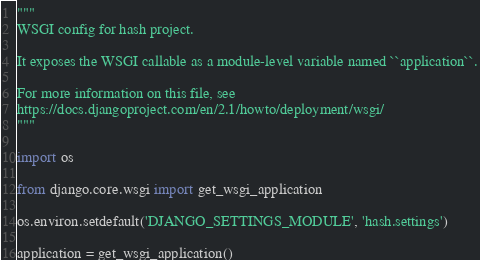Convert code to text. <code><loc_0><loc_0><loc_500><loc_500><_Python_>"""
WSGI config for hash project.

It exposes the WSGI callable as a module-level variable named ``application``.

For more information on this file, see
https://docs.djangoproject.com/en/2.1/howto/deployment/wsgi/
"""

import os

from django.core.wsgi import get_wsgi_application

os.environ.setdefault('DJANGO_SETTINGS_MODULE', 'hash.settings')

application = get_wsgi_application()
</code> 